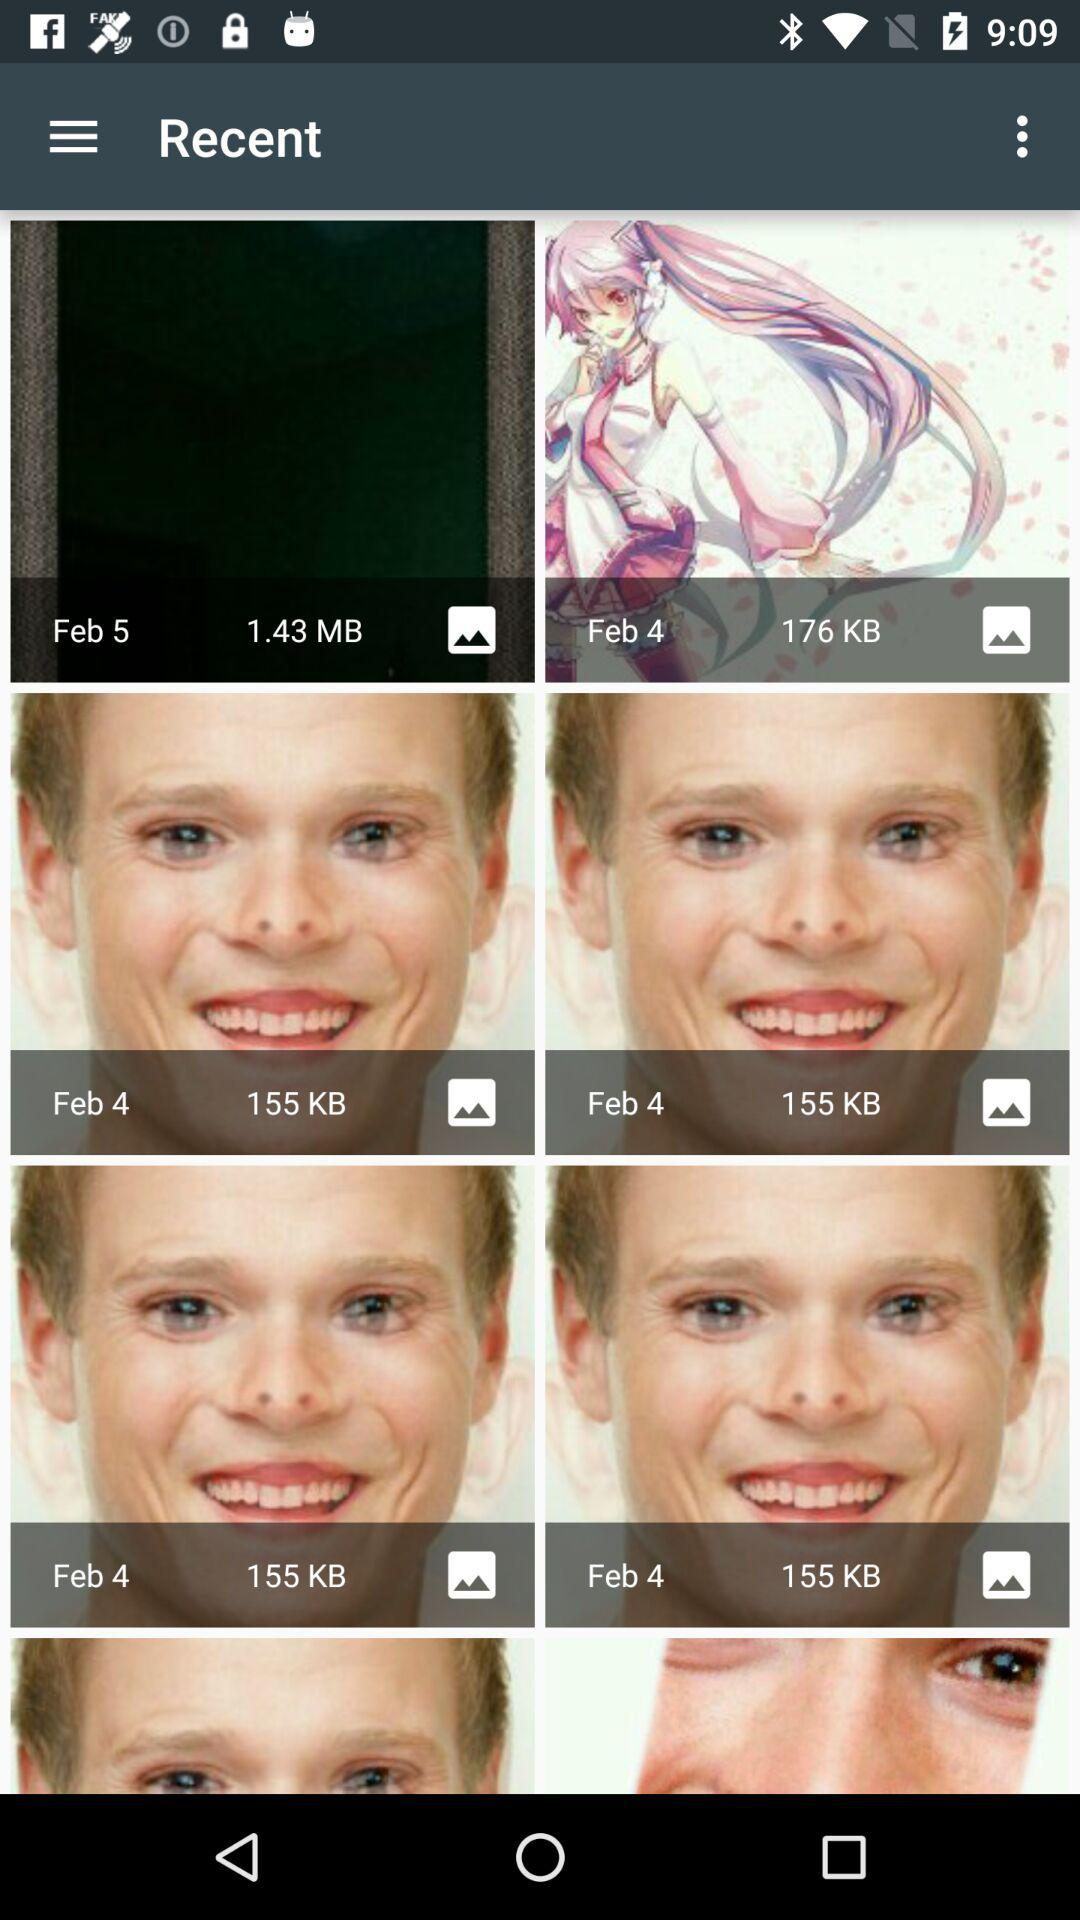What is the size of the picture clicked on February 5th? The size of the picture is 1.43 MB. 